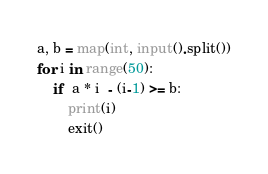<code> <loc_0><loc_0><loc_500><loc_500><_Python_>a, b = map(int, input().split())
for i in range(50):
    if  a * i  - (i-1) >= b:
        print(i)
        exit()</code> 